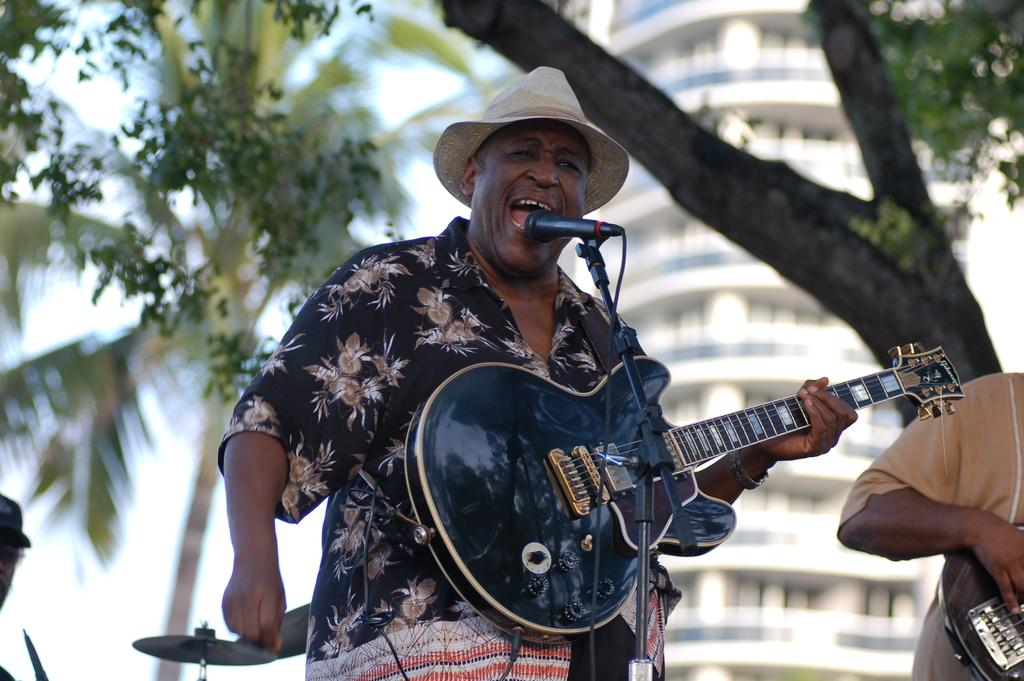How many people are in the image? There are people in the image, but the exact number is not specified. What is one person doing in the image? One person is holding a guitar. What type of apparel is the corn wearing in the image? There is no corn present in the image, and therefore no apparel can be associated with it. 